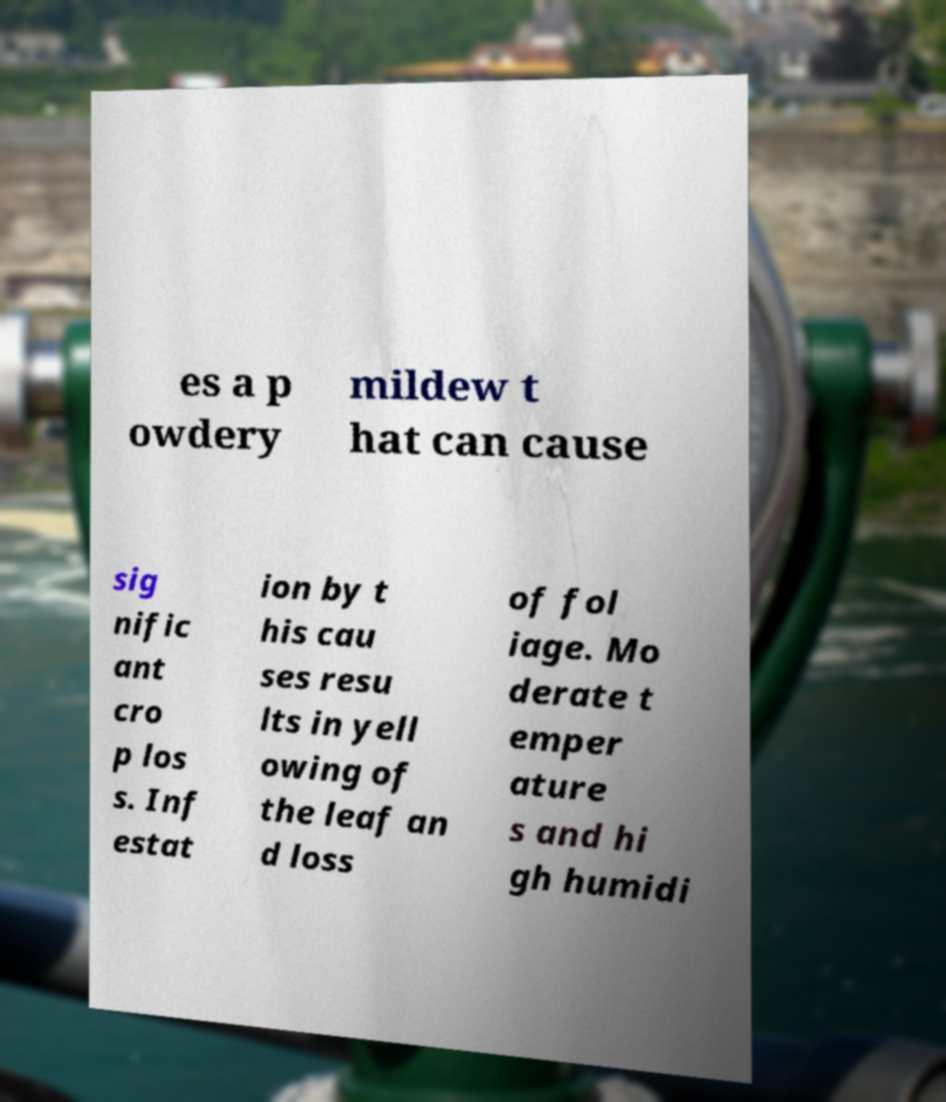Please read and relay the text visible in this image. What does it say? es a p owdery mildew t hat can cause sig nific ant cro p los s. Inf estat ion by t his cau ses resu lts in yell owing of the leaf an d loss of fol iage. Mo derate t emper ature s and hi gh humidi 